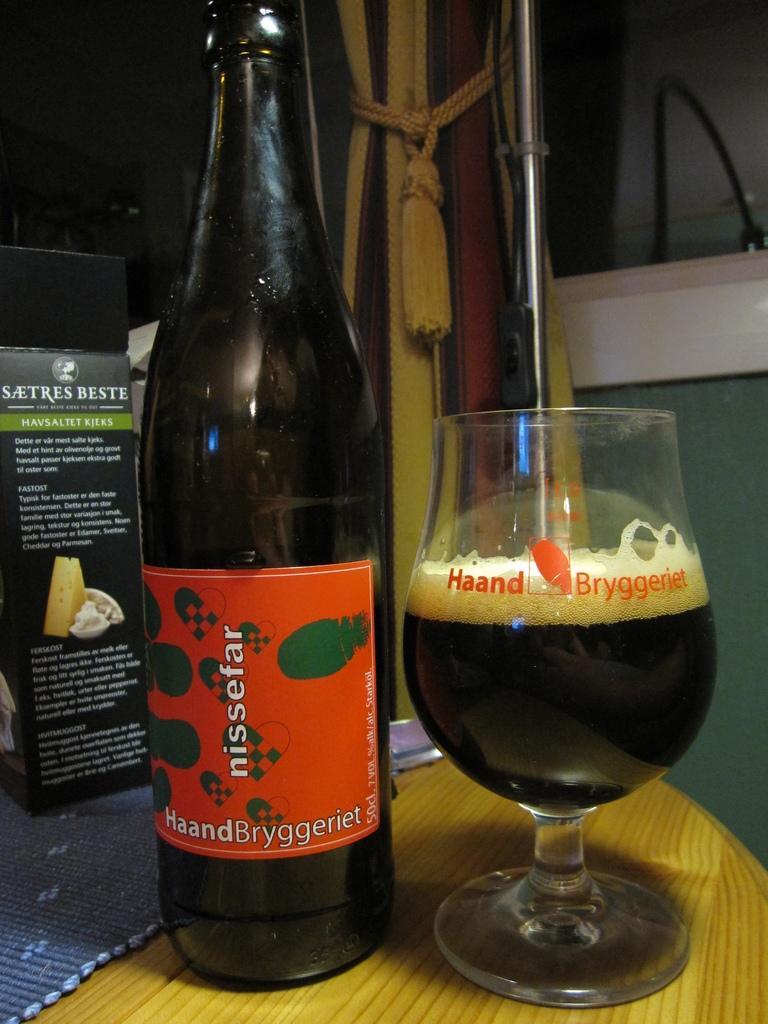How would you summarize this image in a sentence or two? In this image there is a bottle and glass on the bottle. There is a label with text on it. On the glass there is text and in it there is drink and foam on it. Beside the bottle there is another box. On the table there is a cloth. In the background there is wall, a curtain tied to a pillar and a rod. 